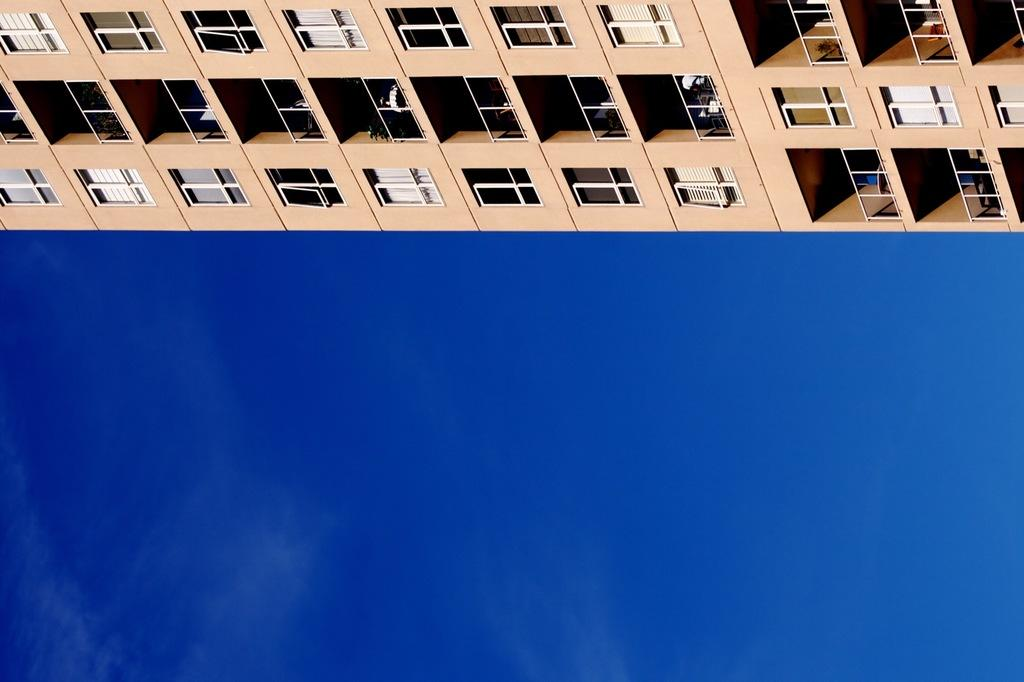What type of structure is visible in the image? There is a building in the image. What material is used for the rods in the image? The rods in the image are made of metal. What type of window treatment is present in the image? There are curtains in the image. What type of powder is being used to clean the queen's example in the image? There is no queen or example present in the image, and therefore no powder can be associated with them. 